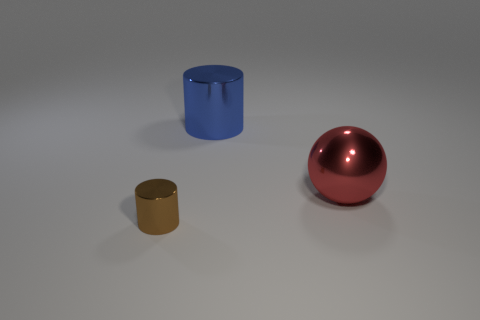Is there any other thing that has the same size as the brown object?
Your answer should be compact. No. Is the number of small metallic cylinders behind the large blue object the same as the number of red metallic spheres?
Give a very brief answer. No. Do the ball and the small cylinder have the same color?
Your answer should be compact. No. Do the large object that is in front of the big blue thing and the metallic thing on the left side of the blue shiny cylinder have the same shape?
Offer a very short reply. No. What material is the other object that is the same shape as the blue metallic object?
Your answer should be very brief. Metal. There is a metallic thing that is both to the right of the brown thing and to the left of the large sphere; what color is it?
Your answer should be very brief. Blue. There is a big object that is to the right of the metallic cylinder behind the tiny cylinder; are there any red things that are behind it?
Offer a very short reply. No. How many objects are brown metallic things or red balls?
Offer a terse response. 2. Do the large blue object and the cylinder in front of the big red shiny thing have the same material?
Your response must be concise. Yes. Is there anything else of the same color as the sphere?
Give a very brief answer. No. 